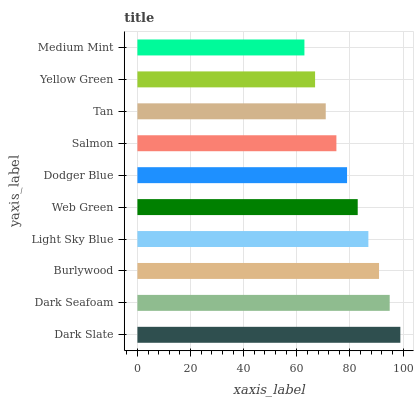Is Medium Mint the minimum?
Answer yes or no. Yes. Is Dark Slate the maximum?
Answer yes or no. Yes. Is Dark Seafoam the minimum?
Answer yes or no. No. Is Dark Seafoam the maximum?
Answer yes or no. No. Is Dark Slate greater than Dark Seafoam?
Answer yes or no. Yes. Is Dark Seafoam less than Dark Slate?
Answer yes or no. Yes. Is Dark Seafoam greater than Dark Slate?
Answer yes or no. No. Is Dark Slate less than Dark Seafoam?
Answer yes or no. No. Is Web Green the high median?
Answer yes or no. Yes. Is Dodger Blue the low median?
Answer yes or no. Yes. Is Dark Slate the high median?
Answer yes or no. No. Is Tan the low median?
Answer yes or no. No. 